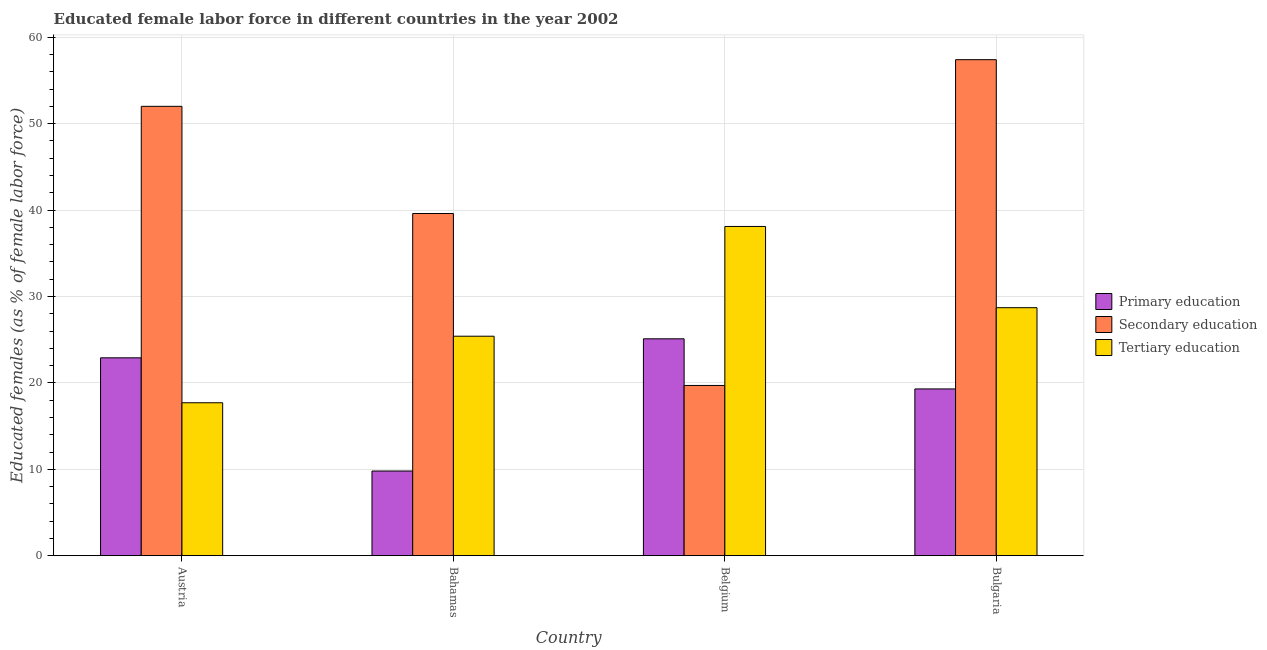How many different coloured bars are there?
Your answer should be compact. 3. How many groups of bars are there?
Provide a succinct answer. 4. Are the number of bars per tick equal to the number of legend labels?
Make the answer very short. Yes. Are the number of bars on each tick of the X-axis equal?
Give a very brief answer. Yes. How many bars are there on the 3rd tick from the left?
Keep it short and to the point. 3. How many bars are there on the 4th tick from the right?
Your response must be concise. 3. What is the label of the 4th group of bars from the left?
Provide a short and direct response. Bulgaria. Across all countries, what is the maximum percentage of female labor force who received primary education?
Ensure brevity in your answer.  25.1. Across all countries, what is the minimum percentage of female labor force who received secondary education?
Make the answer very short. 19.7. What is the total percentage of female labor force who received secondary education in the graph?
Provide a short and direct response. 168.7. What is the difference between the percentage of female labor force who received primary education in Austria and that in Bulgaria?
Offer a terse response. 3.6. What is the difference between the percentage of female labor force who received secondary education in Bahamas and the percentage of female labor force who received primary education in Austria?
Your answer should be very brief. 16.7. What is the average percentage of female labor force who received tertiary education per country?
Offer a terse response. 27.47. What is the difference between the percentage of female labor force who received primary education and percentage of female labor force who received tertiary education in Bahamas?
Give a very brief answer. -15.6. What is the ratio of the percentage of female labor force who received primary education in Austria to that in Bulgaria?
Keep it short and to the point. 1.19. What is the difference between the highest and the second highest percentage of female labor force who received tertiary education?
Your answer should be compact. 9.4. What is the difference between the highest and the lowest percentage of female labor force who received secondary education?
Give a very brief answer. 37.7. What does the 2nd bar from the left in Austria represents?
Provide a succinct answer. Secondary education. What does the 2nd bar from the right in Bahamas represents?
Your response must be concise. Secondary education. Are all the bars in the graph horizontal?
Offer a terse response. No. How many countries are there in the graph?
Ensure brevity in your answer.  4. Where does the legend appear in the graph?
Offer a very short reply. Center right. How many legend labels are there?
Make the answer very short. 3. What is the title of the graph?
Offer a terse response. Educated female labor force in different countries in the year 2002. What is the label or title of the Y-axis?
Offer a terse response. Educated females (as % of female labor force). What is the Educated females (as % of female labor force) in Primary education in Austria?
Provide a short and direct response. 22.9. What is the Educated females (as % of female labor force) in Tertiary education in Austria?
Give a very brief answer. 17.7. What is the Educated females (as % of female labor force) in Primary education in Bahamas?
Ensure brevity in your answer.  9.8. What is the Educated females (as % of female labor force) of Secondary education in Bahamas?
Your answer should be very brief. 39.6. What is the Educated females (as % of female labor force) in Tertiary education in Bahamas?
Your answer should be very brief. 25.4. What is the Educated females (as % of female labor force) in Primary education in Belgium?
Make the answer very short. 25.1. What is the Educated females (as % of female labor force) in Secondary education in Belgium?
Provide a succinct answer. 19.7. What is the Educated females (as % of female labor force) of Tertiary education in Belgium?
Offer a very short reply. 38.1. What is the Educated females (as % of female labor force) of Primary education in Bulgaria?
Offer a terse response. 19.3. What is the Educated females (as % of female labor force) of Secondary education in Bulgaria?
Keep it short and to the point. 57.4. What is the Educated females (as % of female labor force) of Tertiary education in Bulgaria?
Offer a very short reply. 28.7. Across all countries, what is the maximum Educated females (as % of female labor force) in Primary education?
Your answer should be very brief. 25.1. Across all countries, what is the maximum Educated females (as % of female labor force) in Secondary education?
Offer a very short reply. 57.4. Across all countries, what is the maximum Educated females (as % of female labor force) in Tertiary education?
Your answer should be compact. 38.1. Across all countries, what is the minimum Educated females (as % of female labor force) in Primary education?
Your response must be concise. 9.8. Across all countries, what is the minimum Educated females (as % of female labor force) of Secondary education?
Provide a succinct answer. 19.7. Across all countries, what is the minimum Educated females (as % of female labor force) of Tertiary education?
Make the answer very short. 17.7. What is the total Educated females (as % of female labor force) in Primary education in the graph?
Give a very brief answer. 77.1. What is the total Educated females (as % of female labor force) in Secondary education in the graph?
Your response must be concise. 168.7. What is the total Educated females (as % of female labor force) of Tertiary education in the graph?
Your answer should be very brief. 109.9. What is the difference between the Educated females (as % of female labor force) of Tertiary education in Austria and that in Bahamas?
Provide a succinct answer. -7.7. What is the difference between the Educated females (as % of female labor force) of Primary education in Austria and that in Belgium?
Your response must be concise. -2.2. What is the difference between the Educated females (as % of female labor force) of Secondary education in Austria and that in Belgium?
Your response must be concise. 32.3. What is the difference between the Educated females (as % of female labor force) in Tertiary education in Austria and that in Belgium?
Your answer should be compact. -20.4. What is the difference between the Educated females (as % of female labor force) in Secondary education in Austria and that in Bulgaria?
Ensure brevity in your answer.  -5.4. What is the difference between the Educated females (as % of female labor force) in Primary education in Bahamas and that in Belgium?
Your answer should be compact. -15.3. What is the difference between the Educated females (as % of female labor force) in Secondary education in Bahamas and that in Bulgaria?
Provide a succinct answer. -17.8. What is the difference between the Educated females (as % of female labor force) of Tertiary education in Bahamas and that in Bulgaria?
Provide a succinct answer. -3.3. What is the difference between the Educated females (as % of female labor force) of Primary education in Belgium and that in Bulgaria?
Your response must be concise. 5.8. What is the difference between the Educated females (as % of female labor force) of Secondary education in Belgium and that in Bulgaria?
Ensure brevity in your answer.  -37.7. What is the difference between the Educated females (as % of female labor force) in Primary education in Austria and the Educated females (as % of female labor force) in Secondary education in Bahamas?
Your response must be concise. -16.7. What is the difference between the Educated females (as % of female labor force) in Primary education in Austria and the Educated females (as % of female labor force) in Tertiary education in Bahamas?
Your response must be concise. -2.5. What is the difference between the Educated females (as % of female labor force) of Secondary education in Austria and the Educated females (as % of female labor force) of Tertiary education in Bahamas?
Keep it short and to the point. 26.6. What is the difference between the Educated females (as % of female labor force) of Primary education in Austria and the Educated females (as % of female labor force) of Tertiary education in Belgium?
Offer a terse response. -15.2. What is the difference between the Educated females (as % of female labor force) in Primary education in Austria and the Educated females (as % of female labor force) in Secondary education in Bulgaria?
Your answer should be compact. -34.5. What is the difference between the Educated females (as % of female labor force) in Secondary education in Austria and the Educated females (as % of female labor force) in Tertiary education in Bulgaria?
Offer a very short reply. 23.3. What is the difference between the Educated females (as % of female labor force) in Primary education in Bahamas and the Educated females (as % of female labor force) in Tertiary education in Belgium?
Your response must be concise. -28.3. What is the difference between the Educated females (as % of female labor force) of Primary education in Bahamas and the Educated females (as % of female labor force) of Secondary education in Bulgaria?
Provide a succinct answer. -47.6. What is the difference between the Educated females (as % of female labor force) in Primary education in Bahamas and the Educated females (as % of female labor force) in Tertiary education in Bulgaria?
Offer a terse response. -18.9. What is the difference between the Educated females (as % of female labor force) in Secondary education in Bahamas and the Educated females (as % of female labor force) in Tertiary education in Bulgaria?
Keep it short and to the point. 10.9. What is the difference between the Educated females (as % of female labor force) in Primary education in Belgium and the Educated females (as % of female labor force) in Secondary education in Bulgaria?
Make the answer very short. -32.3. What is the difference between the Educated females (as % of female labor force) of Secondary education in Belgium and the Educated females (as % of female labor force) of Tertiary education in Bulgaria?
Offer a terse response. -9. What is the average Educated females (as % of female labor force) of Primary education per country?
Your response must be concise. 19.27. What is the average Educated females (as % of female labor force) of Secondary education per country?
Ensure brevity in your answer.  42.17. What is the average Educated females (as % of female labor force) in Tertiary education per country?
Provide a short and direct response. 27.48. What is the difference between the Educated females (as % of female labor force) of Primary education and Educated females (as % of female labor force) of Secondary education in Austria?
Your answer should be compact. -29.1. What is the difference between the Educated females (as % of female labor force) in Primary education and Educated females (as % of female labor force) in Tertiary education in Austria?
Ensure brevity in your answer.  5.2. What is the difference between the Educated females (as % of female labor force) in Secondary education and Educated females (as % of female labor force) in Tertiary education in Austria?
Your answer should be very brief. 34.3. What is the difference between the Educated females (as % of female labor force) in Primary education and Educated females (as % of female labor force) in Secondary education in Bahamas?
Your answer should be compact. -29.8. What is the difference between the Educated females (as % of female labor force) of Primary education and Educated females (as % of female labor force) of Tertiary education in Bahamas?
Offer a terse response. -15.6. What is the difference between the Educated females (as % of female labor force) of Secondary education and Educated females (as % of female labor force) of Tertiary education in Bahamas?
Make the answer very short. 14.2. What is the difference between the Educated females (as % of female labor force) of Primary education and Educated females (as % of female labor force) of Secondary education in Belgium?
Ensure brevity in your answer.  5.4. What is the difference between the Educated females (as % of female labor force) of Primary education and Educated females (as % of female labor force) of Tertiary education in Belgium?
Keep it short and to the point. -13. What is the difference between the Educated females (as % of female labor force) of Secondary education and Educated females (as % of female labor force) of Tertiary education in Belgium?
Your response must be concise. -18.4. What is the difference between the Educated females (as % of female labor force) of Primary education and Educated females (as % of female labor force) of Secondary education in Bulgaria?
Your response must be concise. -38.1. What is the difference between the Educated females (as % of female labor force) of Primary education and Educated females (as % of female labor force) of Tertiary education in Bulgaria?
Your answer should be very brief. -9.4. What is the difference between the Educated females (as % of female labor force) in Secondary education and Educated females (as % of female labor force) in Tertiary education in Bulgaria?
Give a very brief answer. 28.7. What is the ratio of the Educated females (as % of female labor force) in Primary education in Austria to that in Bahamas?
Provide a short and direct response. 2.34. What is the ratio of the Educated females (as % of female labor force) in Secondary education in Austria to that in Bahamas?
Ensure brevity in your answer.  1.31. What is the ratio of the Educated females (as % of female labor force) of Tertiary education in Austria to that in Bahamas?
Give a very brief answer. 0.7. What is the ratio of the Educated females (as % of female labor force) in Primary education in Austria to that in Belgium?
Your answer should be very brief. 0.91. What is the ratio of the Educated females (as % of female labor force) of Secondary education in Austria to that in Belgium?
Offer a terse response. 2.64. What is the ratio of the Educated females (as % of female labor force) in Tertiary education in Austria to that in Belgium?
Provide a succinct answer. 0.46. What is the ratio of the Educated females (as % of female labor force) of Primary education in Austria to that in Bulgaria?
Ensure brevity in your answer.  1.19. What is the ratio of the Educated females (as % of female labor force) of Secondary education in Austria to that in Bulgaria?
Make the answer very short. 0.91. What is the ratio of the Educated females (as % of female labor force) of Tertiary education in Austria to that in Bulgaria?
Ensure brevity in your answer.  0.62. What is the ratio of the Educated females (as % of female labor force) of Primary education in Bahamas to that in Belgium?
Provide a short and direct response. 0.39. What is the ratio of the Educated females (as % of female labor force) in Secondary education in Bahamas to that in Belgium?
Provide a short and direct response. 2.01. What is the ratio of the Educated females (as % of female labor force) in Tertiary education in Bahamas to that in Belgium?
Make the answer very short. 0.67. What is the ratio of the Educated females (as % of female labor force) in Primary education in Bahamas to that in Bulgaria?
Ensure brevity in your answer.  0.51. What is the ratio of the Educated females (as % of female labor force) in Secondary education in Bahamas to that in Bulgaria?
Ensure brevity in your answer.  0.69. What is the ratio of the Educated females (as % of female labor force) in Tertiary education in Bahamas to that in Bulgaria?
Ensure brevity in your answer.  0.89. What is the ratio of the Educated females (as % of female labor force) of Primary education in Belgium to that in Bulgaria?
Your answer should be very brief. 1.3. What is the ratio of the Educated females (as % of female labor force) in Secondary education in Belgium to that in Bulgaria?
Make the answer very short. 0.34. What is the ratio of the Educated females (as % of female labor force) in Tertiary education in Belgium to that in Bulgaria?
Provide a short and direct response. 1.33. What is the difference between the highest and the second highest Educated females (as % of female labor force) in Tertiary education?
Your answer should be compact. 9.4. What is the difference between the highest and the lowest Educated females (as % of female labor force) in Secondary education?
Offer a very short reply. 37.7. What is the difference between the highest and the lowest Educated females (as % of female labor force) in Tertiary education?
Provide a succinct answer. 20.4. 